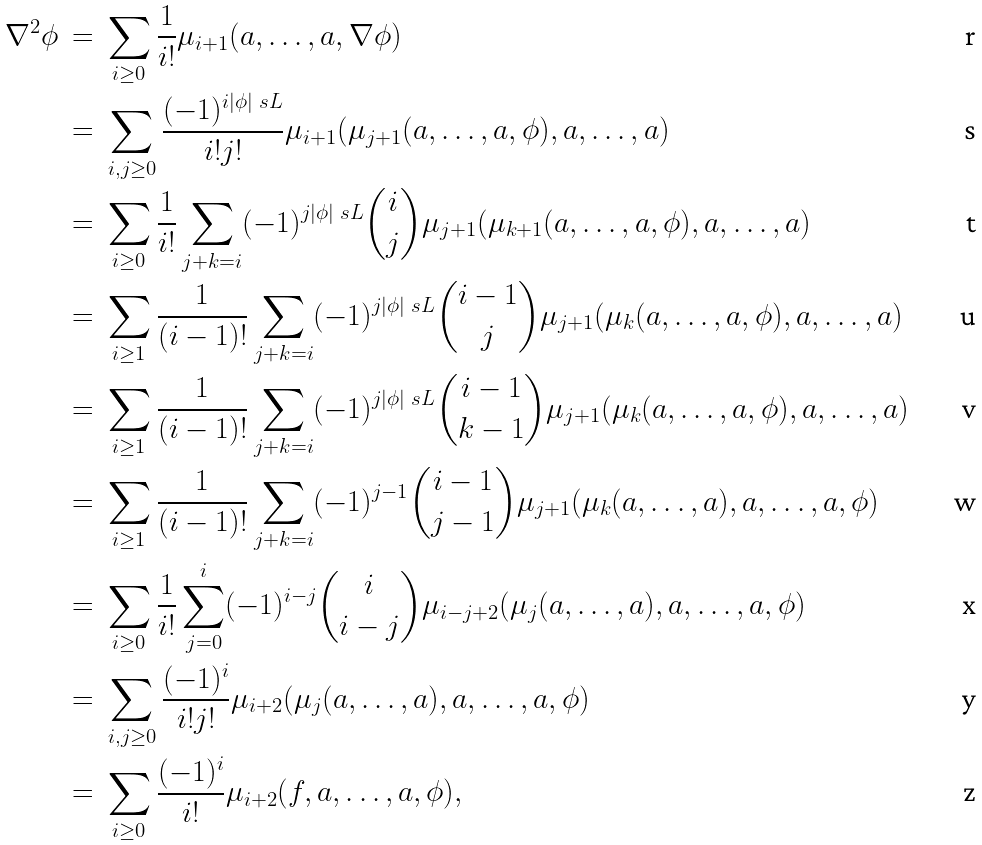Convert formula to latex. <formula><loc_0><loc_0><loc_500><loc_500>\nabla ^ { 2 } \phi \ & = \ \sum _ { i \geq 0 } \frac { 1 } { i ! } \mu _ { i + 1 } ( a , \dots , a , \nabla \phi ) \\ & = \ \sum _ { i , j \geq 0 } \frac { ( - 1 ) ^ { i | \phi | _ { \ } s L } } { i ! j ! } \mu _ { i + 1 } ( \mu _ { j + 1 } ( a , \dots , a , \phi ) , a , \dots , a ) \\ & = \ \sum _ { i \geq 0 } \frac { 1 } { i ! } \sum _ { j + k = i } ( - 1 ) ^ { j | \phi | _ { \ } s L } \binom { i } { j } \mu _ { j + 1 } ( \mu _ { k + 1 } ( a , \dots , a , \phi ) , a , \dots , a ) \\ & = \ \sum _ { i \geq 1 } \frac { 1 } { ( i - 1 ) ! } \sum _ { j + k = i } ( - 1 ) ^ { j | \phi | _ { \ } s L } \binom { i - 1 } { j } \mu _ { j + 1 } ( \mu _ { k } ( a , \dots , a , \phi ) , a , \dots , a ) \\ & = \ \sum _ { i \geq 1 } \frac { 1 } { ( i - 1 ) ! } \sum _ { j + k = i } ( - 1 ) ^ { j | \phi | _ { \ } s L } \binom { i - 1 } { k - 1 } \mu _ { j + 1 } ( \mu _ { k } ( a , \dots , a , \phi ) , a , \dots , a ) \\ & = \ \sum _ { i \geq 1 } \frac { 1 } { ( i - 1 ) ! } \sum _ { j + k = i } ( - 1 ) ^ { j - 1 } \binom { i - 1 } { j - 1 } \mu _ { j + 1 } ( \mu _ { k } ( a , \dots , a ) , a , \dots , a , \phi ) \\ & = \ \sum _ { i \geq 0 } \frac { 1 } { i ! } \sum _ { j = 0 } ^ { i } ( - 1 ) ^ { i - j } \binom { i } { i - j } \mu _ { i - j + 2 } ( \mu _ { j } ( a , \dots , a ) , a , \dots , a , \phi ) \\ & = \ \sum _ { i , j \geq 0 } \frac { ( - 1 ) ^ { i } } { i ! j ! } \mu _ { i + 2 } ( \mu _ { j } ( a , \dots , a ) , a , \dots , a , \phi ) \\ & = \ \sum _ { i \geq 0 } \frac { ( - 1 ) ^ { i } } { i ! } \mu _ { i + 2 } ( f , a , \dots , a , \phi ) ,</formula> 